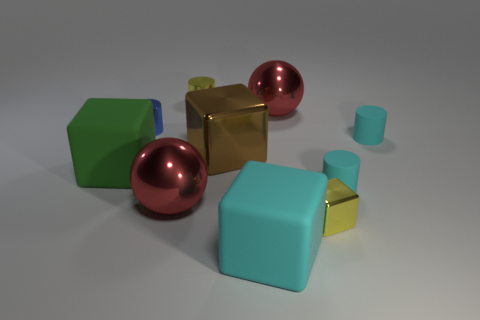Are there the same number of green rubber cubes in front of the blue shiny cylinder and large cyan objects?
Provide a succinct answer. Yes. What number of blue shiny things are right of the big brown metallic object?
Ensure brevity in your answer.  0. The cyan rubber cube is what size?
Make the answer very short. Large. What is the color of the block that is made of the same material as the big cyan thing?
Keep it short and to the point. Green. What number of shiny objects have the same size as the green rubber thing?
Provide a succinct answer. 3. Is the material of the large red sphere on the right side of the yellow cylinder the same as the big cyan cube?
Provide a succinct answer. No. Is the number of matte cylinders behind the blue shiny object less than the number of yellow things?
Provide a short and direct response. Yes. The big thing that is on the left side of the blue thing has what shape?
Your answer should be very brief. Cube. What is the shape of the yellow object that is the same size as the yellow metallic cube?
Give a very brief answer. Cylinder. Is there a tiny blue metal thing that has the same shape as the big cyan thing?
Offer a terse response. No. 